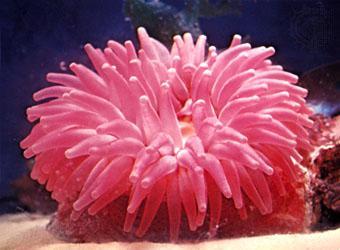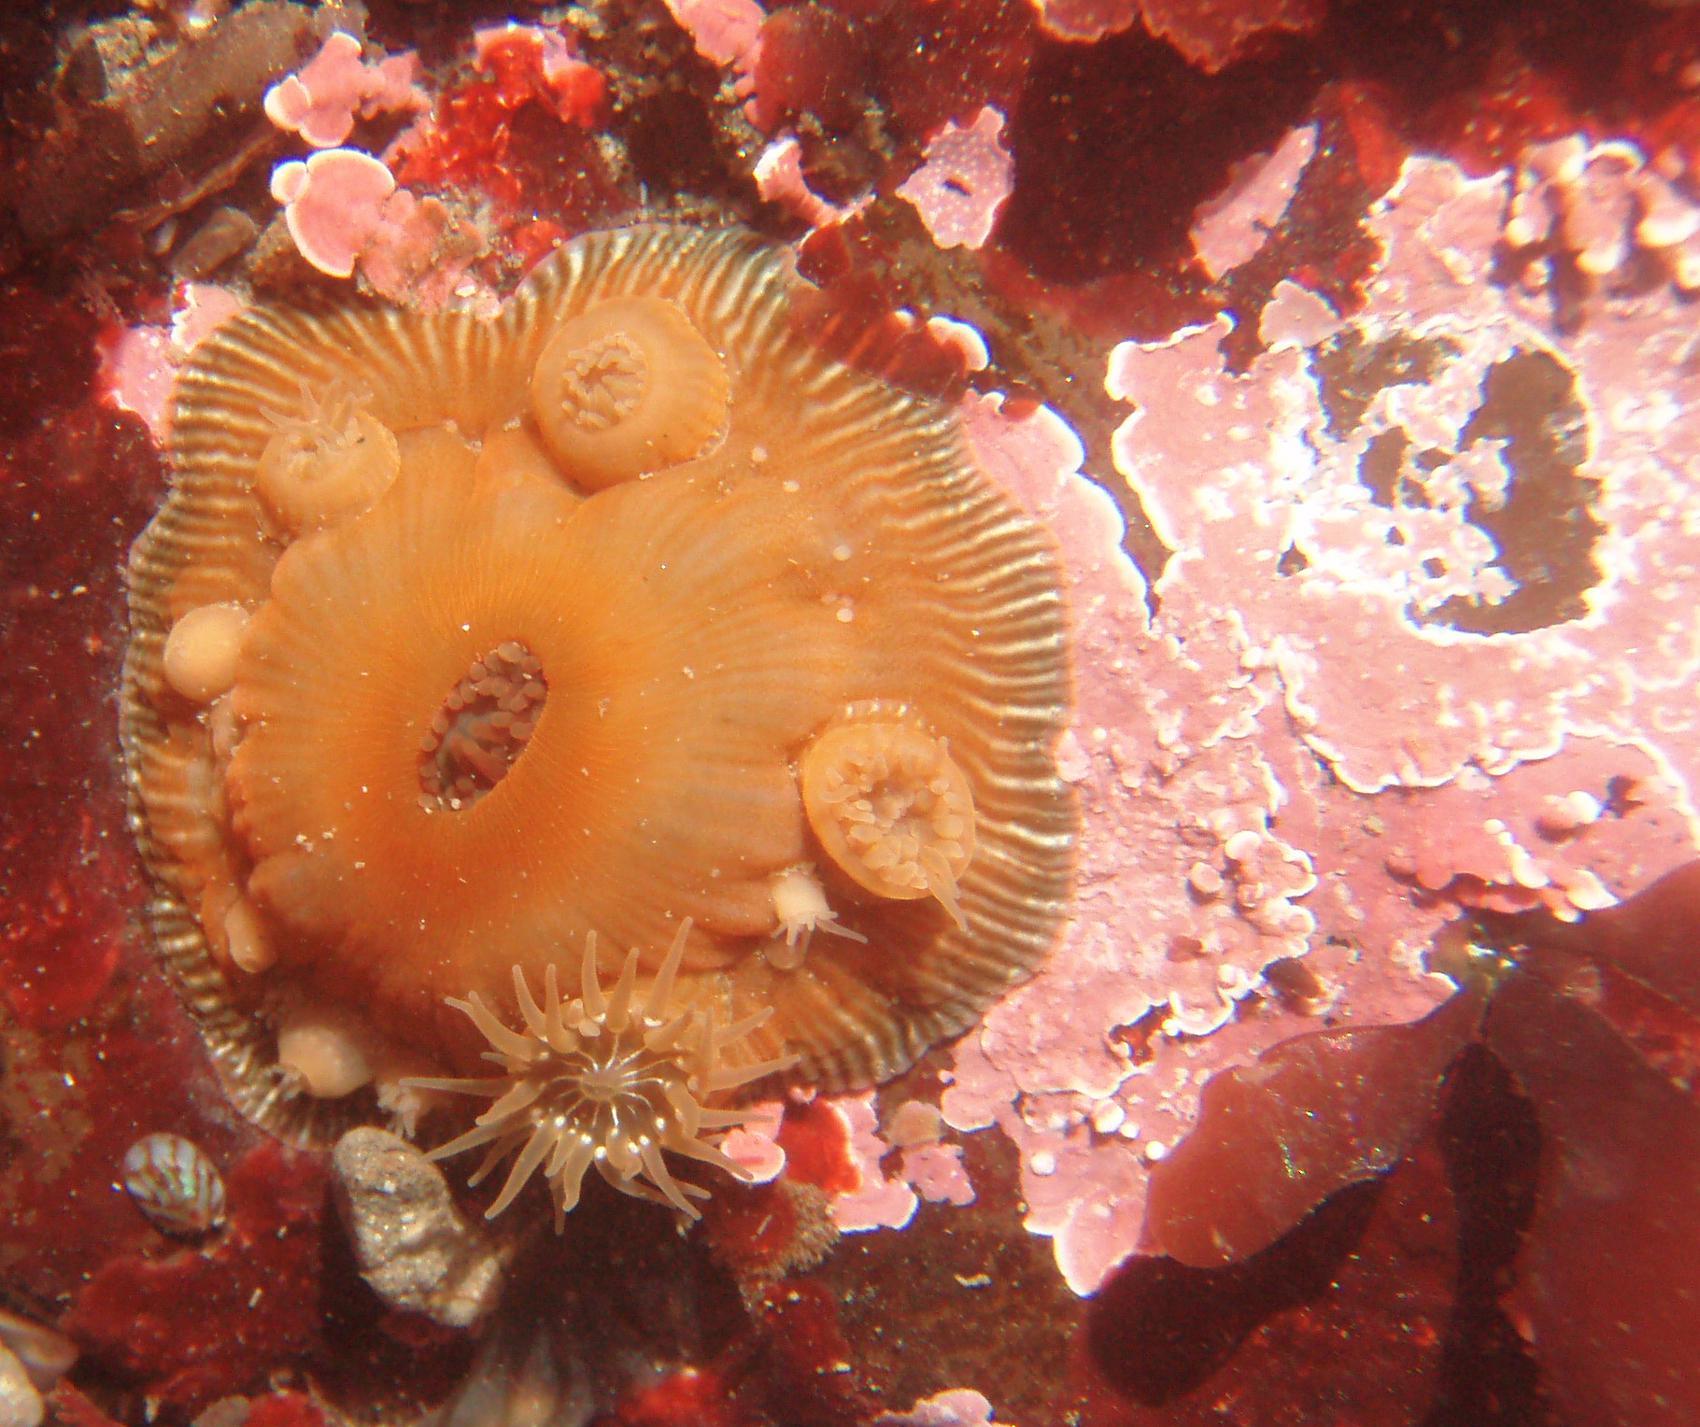The first image is the image on the left, the second image is the image on the right. For the images displayed, is the sentence "There is no more than one pink anemone." factually correct? Answer yes or no. Yes. The first image is the image on the left, the second image is the image on the right. Analyze the images presented: Is the assertion "An anemone looks like a pink flower with tubular monochromatic petals." valid? Answer yes or no. Yes. 